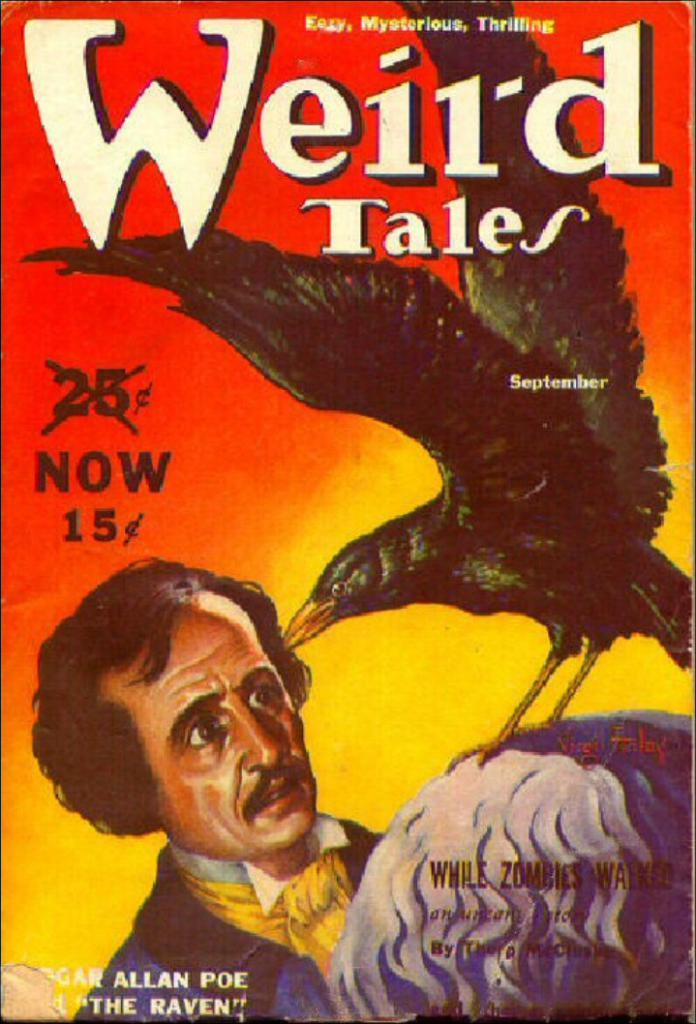<image>
Create a compact narrative representing the image presented. The cover of Weird Tales has an orange and yellow background. 